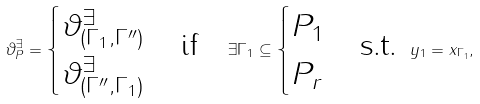Convert formula to latex. <formula><loc_0><loc_0><loc_500><loc_500>\vartheta ^ { \exists } _ { P } = \begin{cases} \vartheta ^ { \exists } _ { ( \Gamma _ { 1 } , \Gamma ^ { \prime \prime } ) } \\ \vartheta ^ { \exists } _ { ( \Gamma ^ { \prime \prime } , \Gamma _ { 1 } ) } \end{cases} \text {if} \quad \exists \Gamma _ { 1 } \subseteq \begin{cases} P _ { 1 } \\ P _ { r } \end{cases} \text {s.t. } y _ { 1 } = x _ { \Gamma _ { 1 } } ,</formula> 